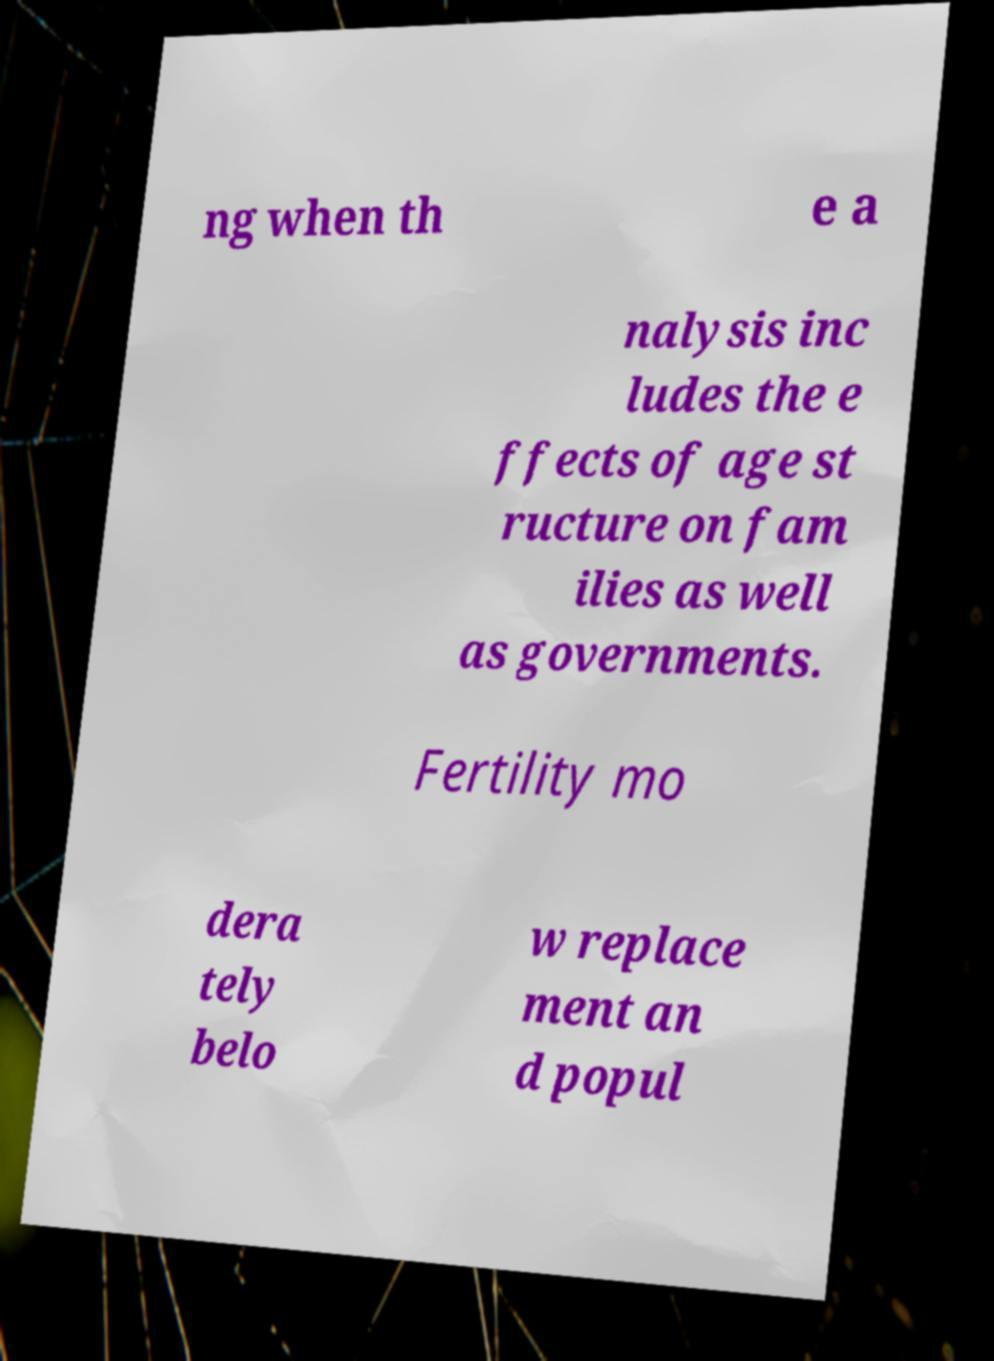Could you extract and type out the text from this image? ng when th e a nalysis inc ludes the e ffects of age st ructure on fam ilies as well as governments. Fertility mo dera tely belo w replace ment an d popul 